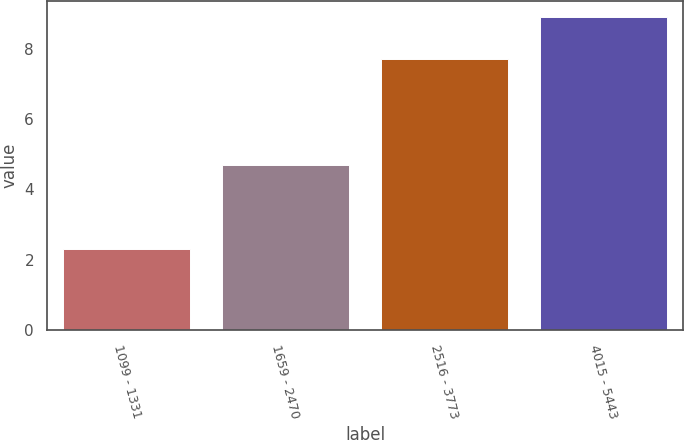Convert chart to OTSL. <chart><loc_0><loc_0><loc_500><loc_500><bar_chart><fcel>1099 - 1331<fcel>1659 - 2470<fcel>2516 - 3773<fcel>4015 - 5443<nl><fcel>2.3<fcel>4.7<fcel>7.7<fcel>8.9<nl></chart> 